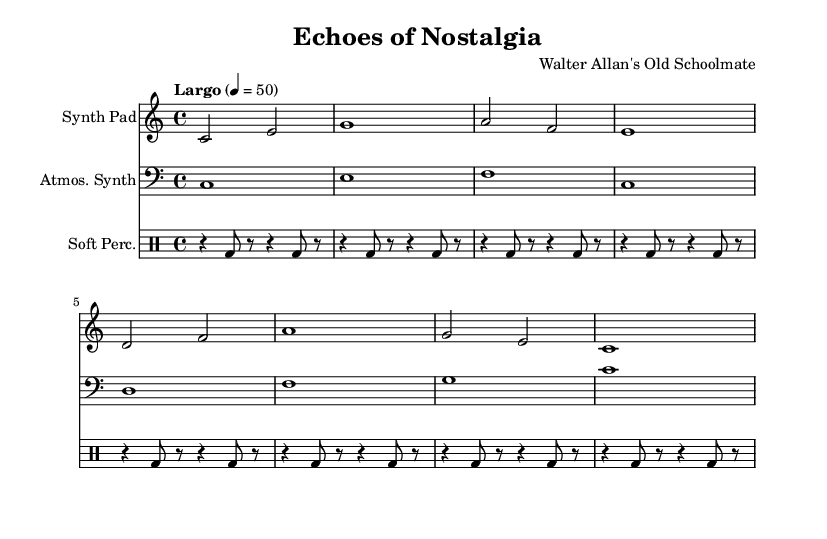What is the key signature of this music? The key signature is indicated at the beginning of the score, showing no sharps or flats, which corresponds to C major.
Answer: C major What is the time signature of this piece? The time signature is displayed at the beginning of the score as 4/4, suggesting four beats in a measure.
Answer: 4/4 What is the tempo marking for the music? The tempo marking is shown as "Largo" with a metronome mark of quarter note equals 50, indicating a slow pace for the piece.
Answer: Largo, 50 How many measures are in the 'Synth Pad' section? By counting the individual bar lines in the 'Synth Pad' section, there are a total of eight measures present.
Answer: Eight Which instrument plays the bass clef? The score shows that the 'Atmospheric Synth' part is written in the bass clef, indicating it is played by that instrument.
Answer: Atmospheric Synth How often does the soft percussion pattern repeat in the music? The 'Soft Percussion' section contains a repeated pattern that occurs every two measures, demonstrating a consistent rhythmic loop.
Answer: Every two measures What is the texture of the music in terms of instrumentation? The music features a layered texture with three distinct instrumental parts: Synth Pad, Atmospheric Synth, and Soft Percussion.
Answer: Layered 